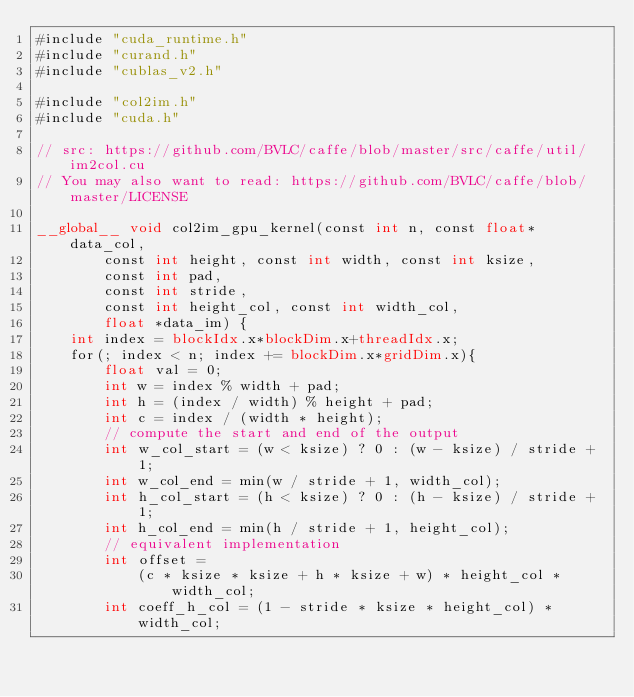<code> <loc_0><loc_0><loc_500><loc_500><_Cuda_>#include "cuda_runtime.h"
#include "curand.h"
#include "cublas_v2.h"

#include "col2im.h"
#include "cuda.h"

// src: https://github.com/BVLC/caffe/blob/master/src/caffe/util/im2col.cu
// You may also want to read: https://github.com/BVLC/caffe/blob/master/LICENSE

__global__ void col2im_gpu_kernel(const int n, const float* data_col,
        const int height, const int width, const int ksize,
        const int pad,
        const int stride,
        const int height_col, const int width_col,
        float *data_im) {
    int index = blockIdx.x*blockDim.x+threadIdx.x;
    for(; index < n; index += blockDim.x*gridDim.x){
        float val = 0;
        int w = index % width + pad;
        int h = (index / width) % height + pad;
        int c = index / (width * height);
        // compute the start and end of the output
        int w_col_start = (w < ksize) ? 0 : (w - ksize) / stride + 1;
        int w_col_end = min(w / stride + 1, width_col);
        int h_col_start = (h < ksize) ? 0 : (h - ksize) / stride + 1;
        int h_col_end = min(h / stride + 1, height_col);
        // equivalent implementation
        int offset =
            (c * ksize * ksize + h * ksize + w) * height_col * width_col;
        int coeff_h_col = (1 - stride * ksize * height_col) * width_col;</code> 